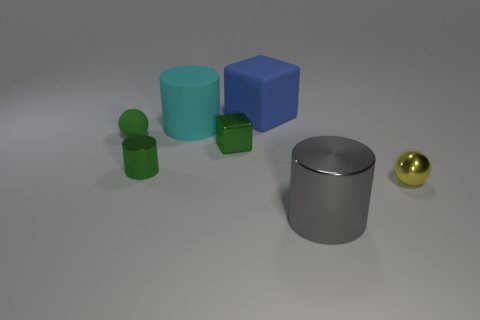What number of green metal blocks are the same size as the green cylinder?
Your response must be concise. 1. What is the color of the big cube?
Your answer should be compact. Blue. Do the large shiny cylinder and the metal cylinder left of the large gray cylinder have the same color?
Ensure brevity in your answer.  No. What size is the cube that is the same material as the cyan cylinder?
Offer a terse response. Large. Are there any tiny metallic cylinders of the same color as the large block?
Provide a short and direct response. No. What number of things are big things that are in front of the large block or tiny brown balls?
Offer a very short reply. 2. Do the big cyan cylinder and the ball that is on the right side of the large metallic cylinder have the same material?
Give a very brief answer. No. What is the size of the metal cylinder that is the same color as the rubber sphere?
Offer a terse response. Small. Is there a gray cylinder that has the same material as the small cube?
Your response must be concise. Yes. How many objects are either big things on the right side of the blue thing or big things that are in front of the yellow sphere?
Provide a short and direct response. 1. 